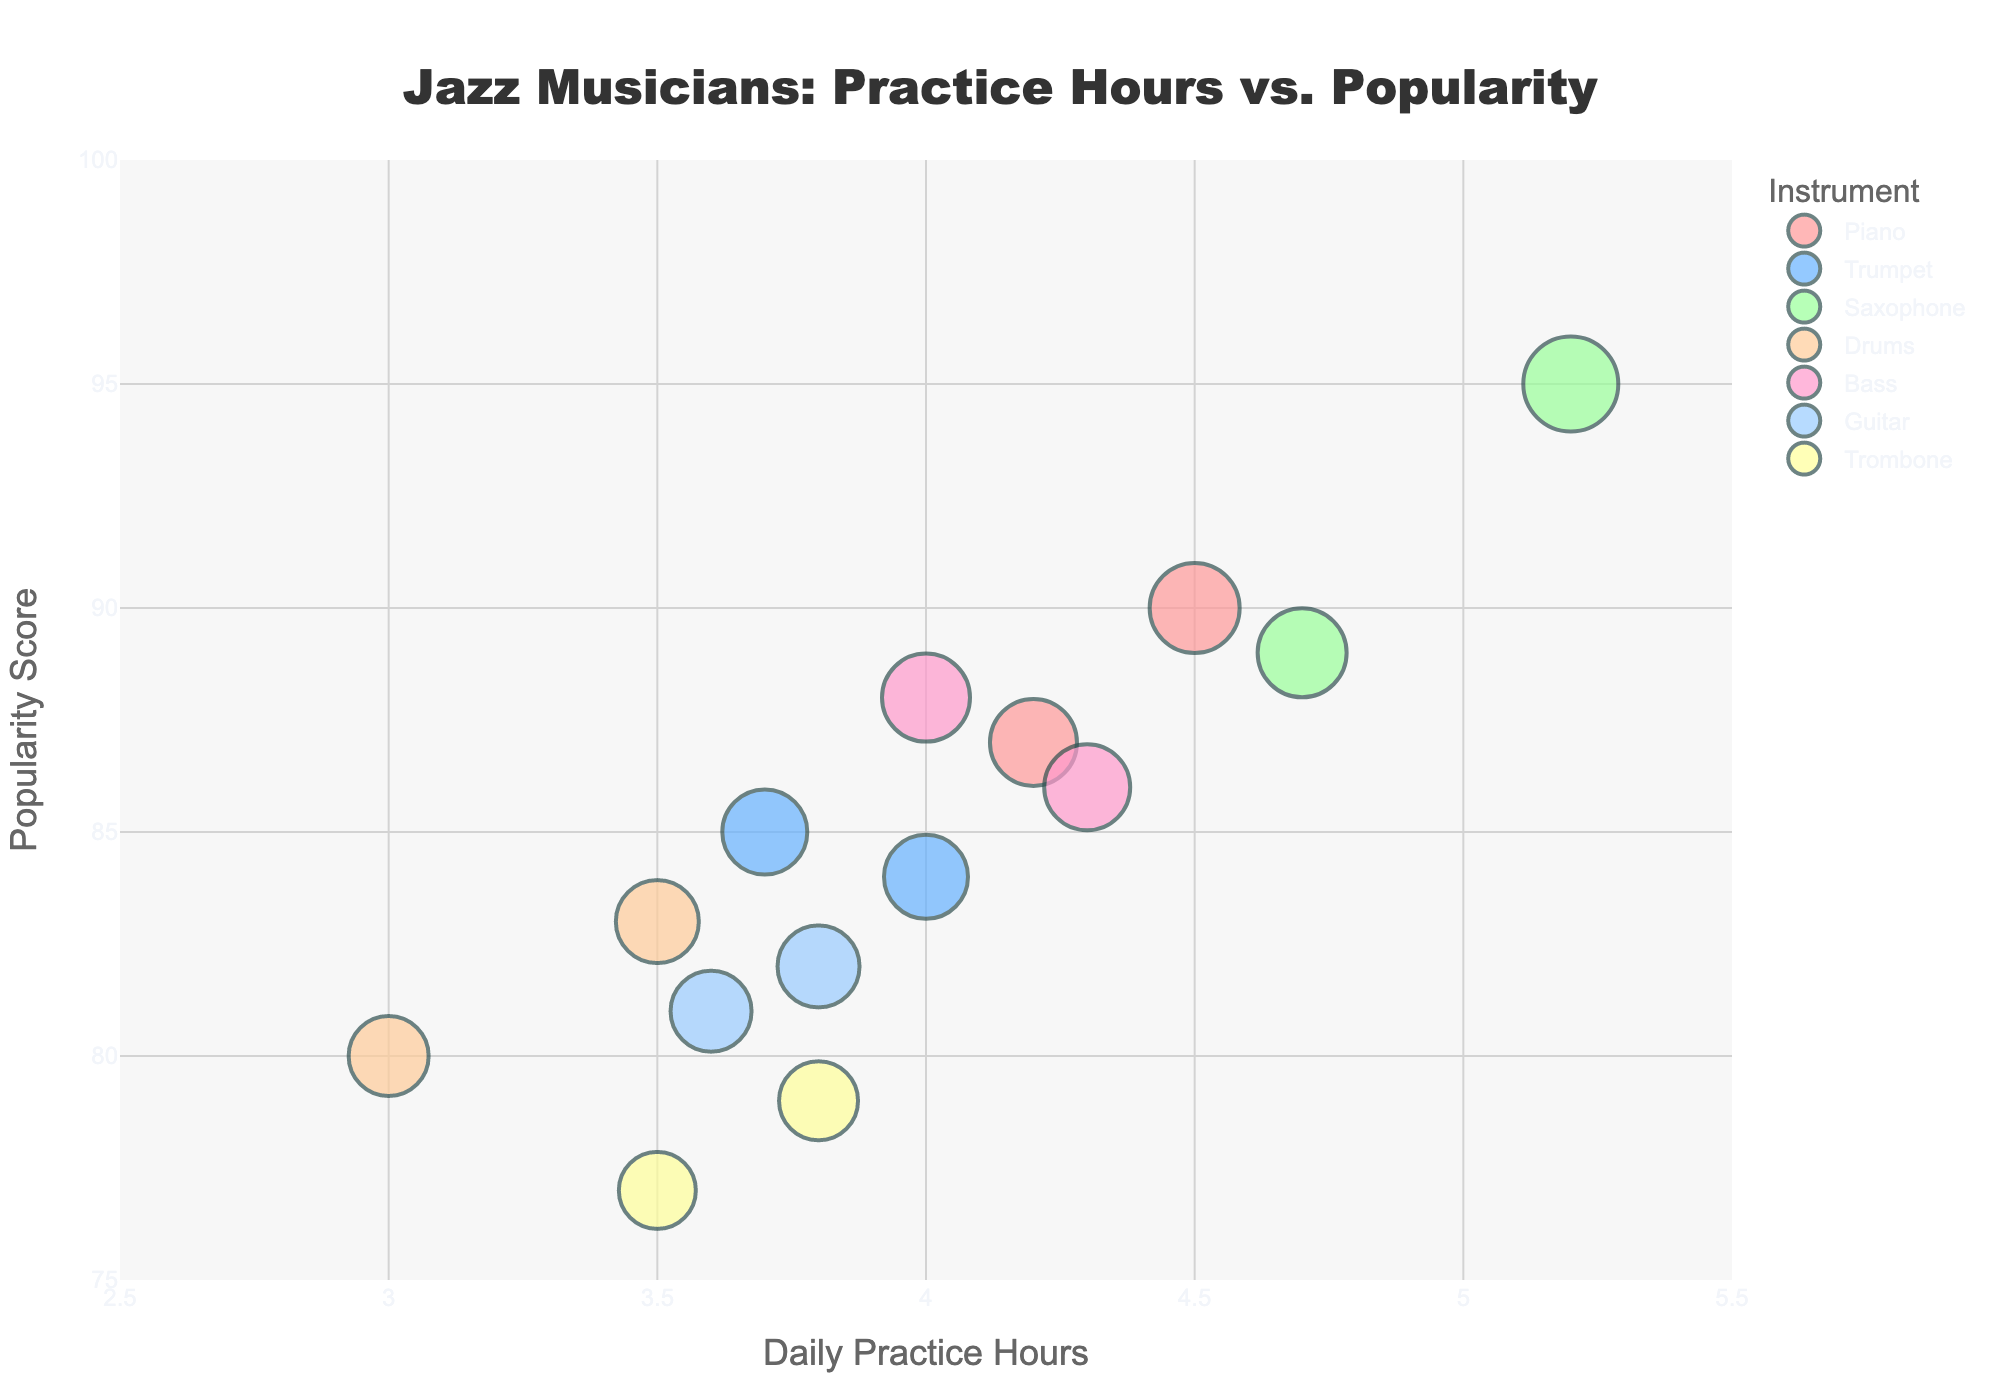What is the title of the chart? The title is displayed prominently at the top center of the chart and reads "Jazz Musicians: Practice Hours vs. Popularity".
Answer: Jazz Musicians: Practice Hours vs. Popularity How many musicians practice more than 4 hours a day? By inspecting the x-axis for values greater than 4 and counting the corresponding data points, there are musicians practicing over that threshold.
Answer: 6 Which instrument has the musician with the highest popularity score, and what is that score? The highest popularity score can be seen on the y-axis at the top range (close to 95). The instrument associated with it has to be located with the closest marker. The musician with a 95 popularity score plays Saxophone.
Answer: Saxophone, 95 Which musician practicing the least hours still has a popularity score above 80? Find the marker with the smallest x-value (practice hours) above 80 on the y-axis. Art Blakey, a drummer, is practicing 3 hours while having a popularity score of 80.
Answer: Art Blakey What is the average practice time for pianists? Identify all markers for pianists, note their practice hours (4.5 for Keith Jarrett and 4.2 for Bill Evans), and calculate the average: (4.5 + 4.2) / 2 = 4.35 hours.
Answer: 4.35 hours Are there more saxophonists or trumpet players practicing daily between 4 and 5 hours? Count the markers for both saxophonists and trumpet players that fall within the 4 to 5 practice hours range on the x-axis. There are 2 saxophonists (Cannonball Adderley, John Coltrane) and 1 trumpet player (Dizzy Gillespie).
Answer: Saxophonists Which instrument has the largest bubble size, indicating the highest popularity? Look for the largest bubble on the chart, and note its instrument type. The largest bubble representing the highest popularity belongs to the Saxophone (John Coltrane, score 95).
Answer: Saxophone What is the range of popularity scores covered by guitar players? Check the top and bottom most positions of the bubbles that represent guitar players on the y-axis. The range for guitar players (Wes Montgomery and Joe Pass) is between 81 and 82.
Answer: 81 to 82 Which musician practicing around 3.5 hours has the highest popularity score, and what instrument do they play? Identify markers near 3.5 on the x-axis and compare their y-values. Max Roach (Drums) has the highest popularity score at 83 when practicing around 3.5 hours.
Answer: Max Roach, Drums What is the total number of different instruments played by the musicians in the chart? Count the unique instruments listed in the legend of the chart. There are 7 different instruments: Piano, Trumpet, Saxophone, Drums, Bass, Guitar, Trombone.
Answer: 7 